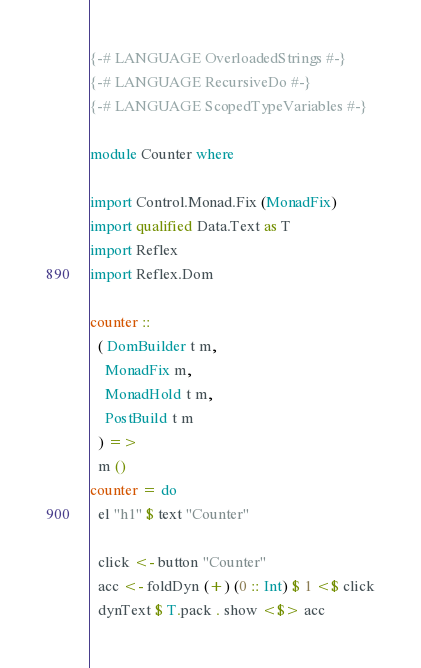Convert code to text. <code><loc_0><loc_0><loc_500><loc_500><_Haskell_>{-# LANGUAGE OverloadedStrings #-}
{-# LANGUAGE RecursiveDo #-}
{-# LANGUAGE ScopedTypeVariables #-}

module Counter where

import Control.Monad.Fix (MonadFix)
import qualified Data.Text as T
import Reflex
import Reflex.Dom

counter ::
  ( DomBuilder t m,
    MonadFix m,
    MonadHold t m,
    PostBuild t m
  ) =>
  m ()
counter = do
  el "h1" $ text "Counter"

  click <- button "Counter"
  acc <- foldDyn (+) (0 :: Int) $ 1 <$ click
  dynText $ T.pack . show <$> acc
</code> 